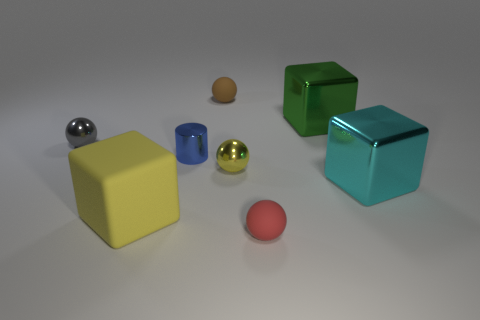What is the material of the large object that is behind the gray sphere that is left of the brown ball?
Keep it short and to the point. Metal. How many tiny metal spheres are the same color as the matte cube?
Offer a very short reply. 1. Are there fewer metal objects in front of the cyan shiny cube than large red balls?
Ensure brevity in your answer.  No. What color is the tiny matte object on the left side of the matte sphere that is in front of the yellow metal ball?
Give a very brief answer. Brown. There is a yellow thing that is behind the big yellow thing that is to the left of the thing right of the large green thing; what size is it?
Offer a terse response. Small. Are there fewer large cyan metal blocks that are to the left of the large green block than tiny brown rubber spheres behind the red rubber thing?
Provide a succinct answer. Yes. What number of tiny red objects are the same material as the small gray sphere?
Your answer should be very brief. 0. Are there any big objects that are left of the small rubber thing behind the green shiny block behind the red rubber sphere?
Keep it short and to the point. Yes. There is a tiny yellow object that is the same material as the cyan thing; what is its shape?
Offer a very short reply. Sphere. Is the number of gray balls greater than the number of large cyan metal balls?
Make the answer very short. Yes. 